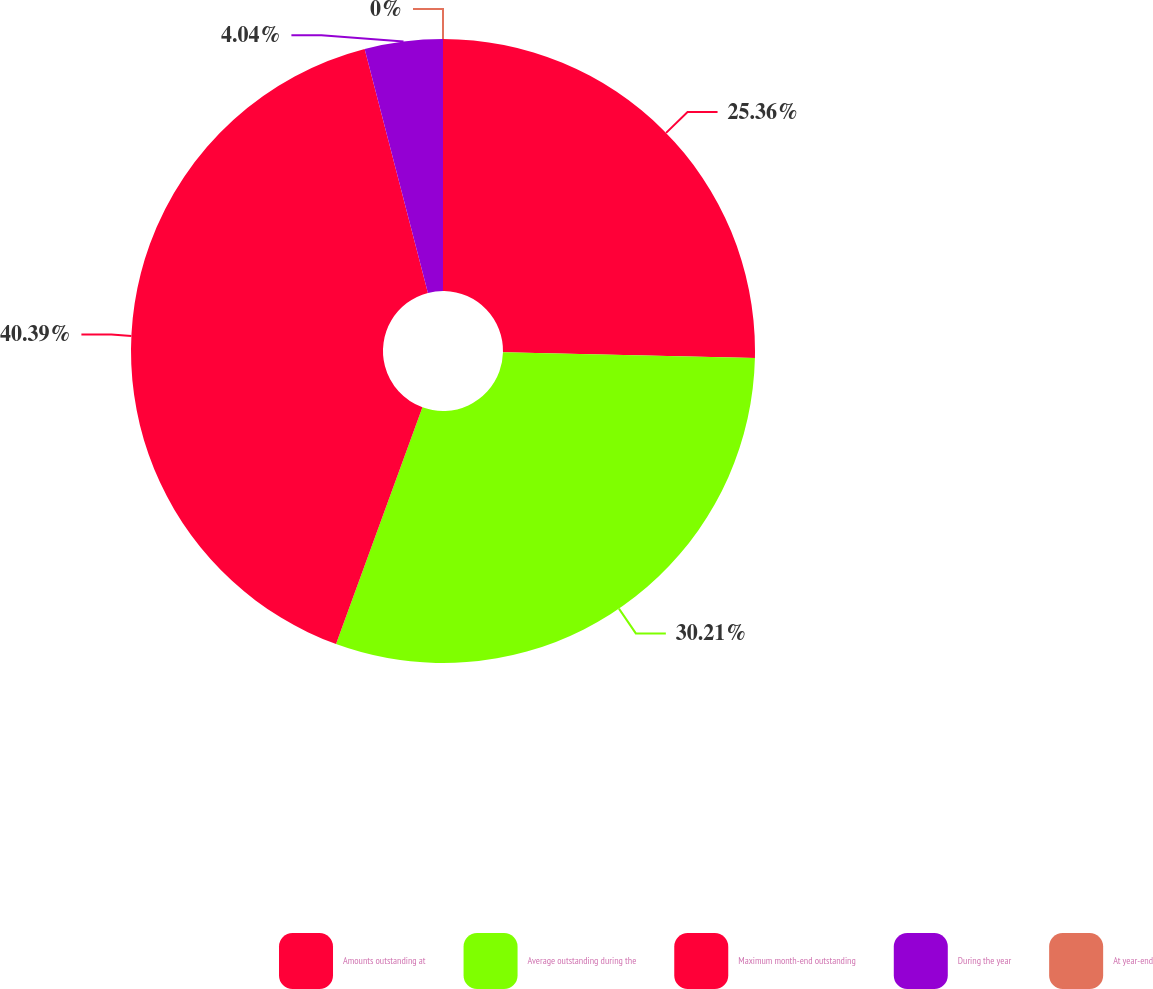Convert chart to OTSL. <chart><loc_0><loc_0><loc_500><loc_500><pie_chart><fcel>Amounts outstanding at<fcel>Average outstanding during the<fcel>Maximum month-end outstanding<fcel>During the year<fcel>At year-end<nl><fcel>25.36%<fcel>30.21%<fcel>40.39%<fcel>4.04%<fcel>0.0%<nl></chart> 